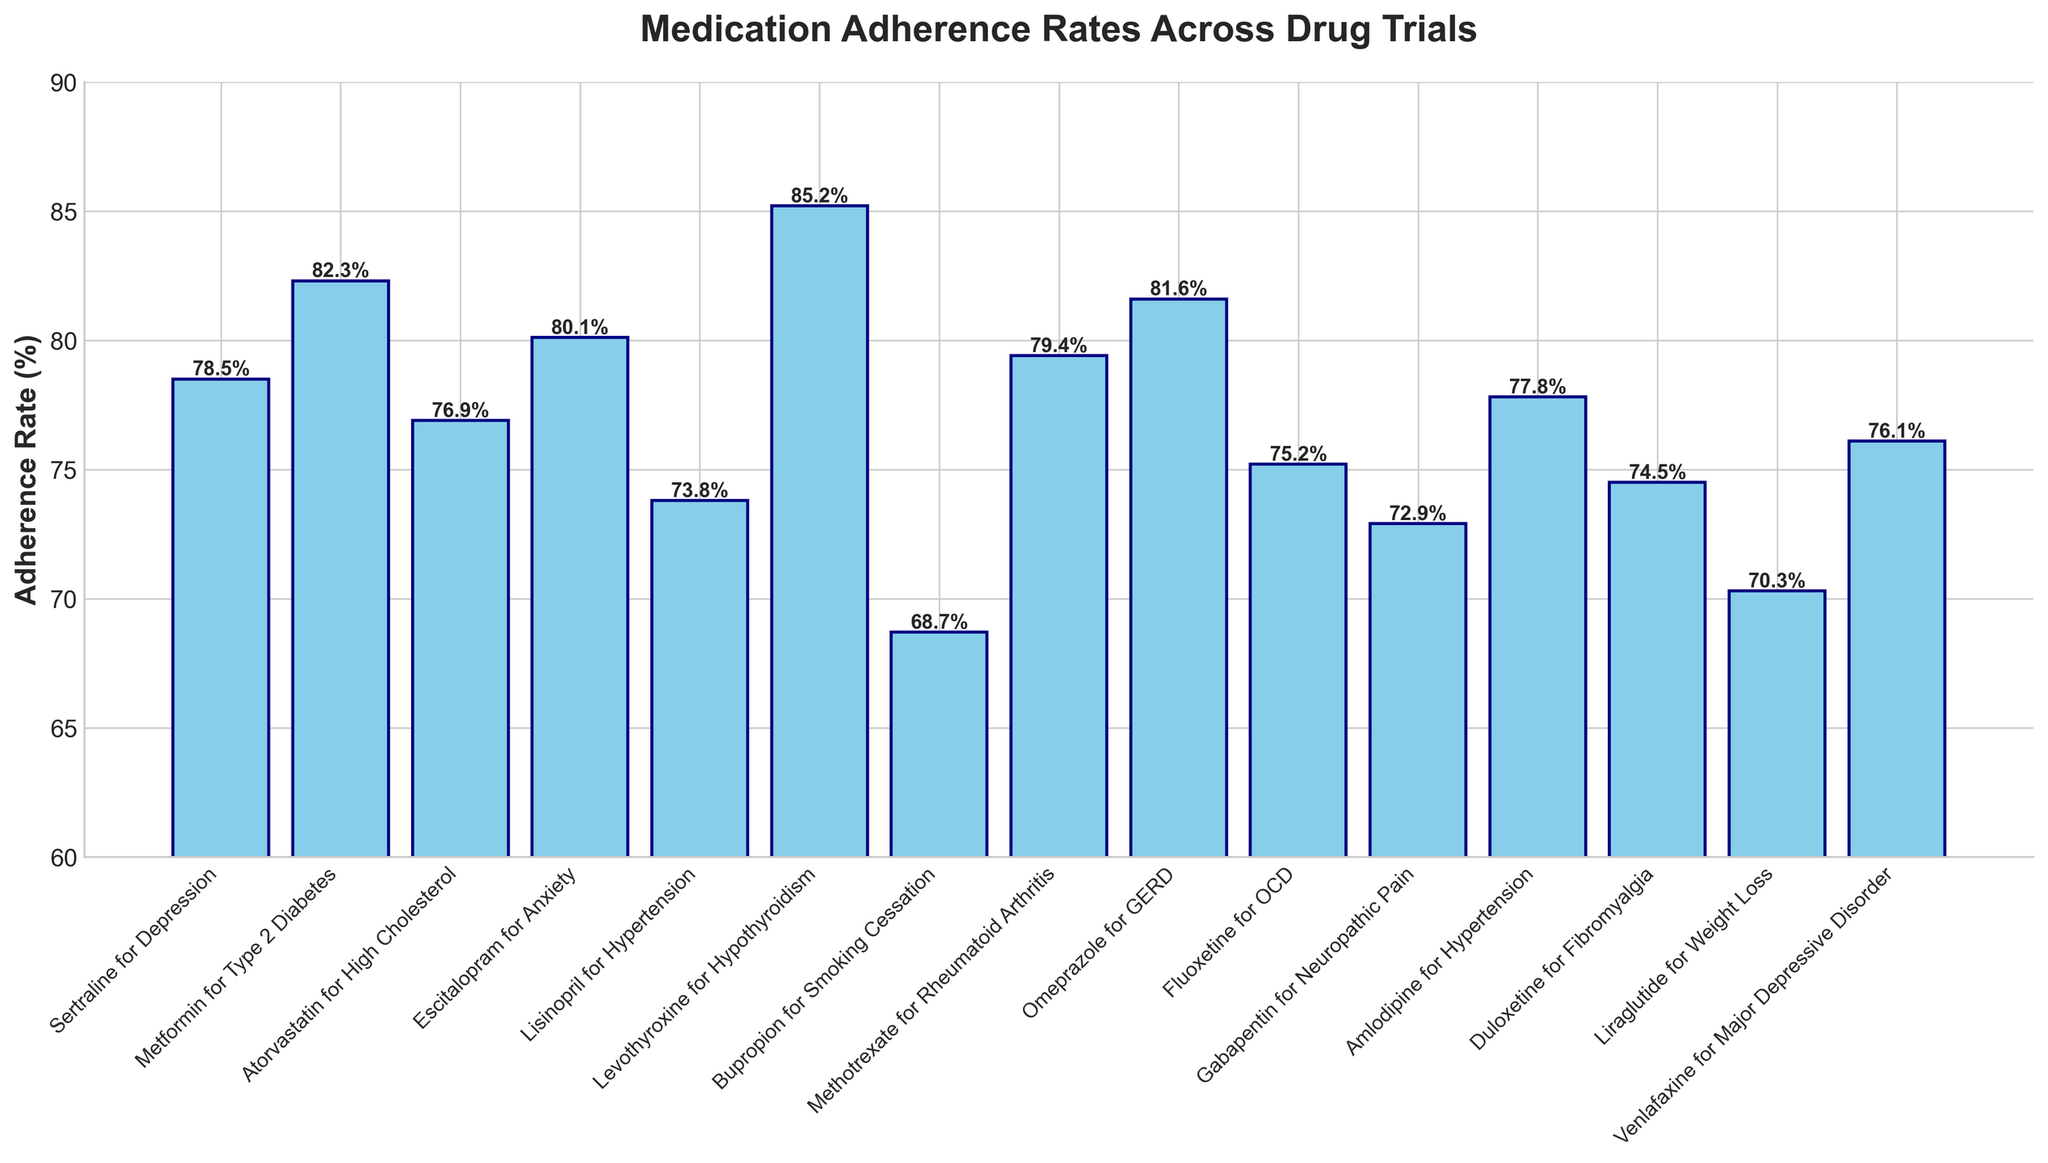Which drug trial has the highest adherence rate? The bar with the highest endpoint represents the highest adherence rate. Levothyroxine for Hypothyroidism has the tallest bar, indicating the highest adherence at 85.2%.
Answer: Levothyroxine for Hypothyroidism Which drug trial has the lowest adherence rate? The bar with the lowest endpoint represents the lowest adherence rate. Bupropion for Smoking Cessation has the shortest bar, indicating the lowest adherence at 68.7%.
Answer: Bupropion for Smoking Cessation What's the difference in adherence rates between Sertraline for Depression and Amlodipine for Hypertension? From the figure, identify the heights of the two bars: Sertraline for Depression is 78.5 and Amlodipine for Hypertension is 77.8. The difference is found by subtraction: 78.5 - 77.8 = 0.7%.
Answer: 0.7% What is the average adherence rate for the trials with rates above 80%? Identify bars above 80%: Metformin for Type 2 Diabetes (82.3%), Escitalopram for Anxiety (80.1%), Levothyroxine for Hypothyroidism (85.2%), Omeprazole for GERD (81.6%). Compute the average: (82.3 + 80.1 + 85.2 + 81.6) / 4 = 82.3%.
Answer: 82.3% Which two drug trials have the closest adherence rates? Look for bars with similar heights. Metformin for Type 2 Diabetes (82.3%) and Omeprazole for GERD (81.6%) have adherence rates that are very close to each other. The difference is 82.3 - 81.6 = 0.7%.
Answer: Metformin for Type 2 Diabetes and Omeprazole for GERD How much higher is the adherence rate of Escitalopram for Anxiety compared to Lisinopril for Hypertension? Identify the heights: Escitalopram for Anxiety (80.1%) and Lisinopril for Hypertension (73.8%). Subtract: 80.1 - 73.8 = 6.3%.
Answer: 6.3% What is the median adherence rate of all the drug trials? List all adherence rates and find the median: 68.7, 70.3, 72.9, 73.8, 74.5, 75.2, 76.1, 76.9, 77.8, 78.5, 79.4, 80.1, 81.6, 82.3, 85.2. The median is the middle value: 76.9%.
Answer: 76.9% How many drug trials have adherence rates below 75%? Count the number of bars below the 75% mark: Bupropion for Smoking Cessation (68.7%), Liraglutide for Weight Loss (70.3%), Gabapentin for Neuropathic Pain (72.9%), Lisinopril for Hypertension (73.8%), Duloxetine for Fibromyalgia (74.5%). Total is 5.
Answer: 5 Which drug trial's adherence rate is closest to the midpoint of the range 60%-90%? Midpoint of 60-90% is 75%. Find the bar closest to this value: Fluoxetine for OCD at 75.2% is closest to 75%.
Answer: Fluoxetine for OCD What's the total adherence rate of all drug trials combined? Sum all adherence rates: 78.5 + 82.3 + 76.9 + 80.1 + 73.8 + 85.2 + 68.7 + 79.4 + 81.6 + 75.2 + 72.9 + 77.8 + 74.5 + 70.3 + 76.1 = 1253.3%.
Answer: 1253.3% 